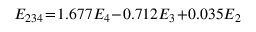<formula> <loc_0><loc_0><loc_500><loc_500>\begin{array} { r } { E _ { 2 3 4 } \, = \, 1 . 6 7 7 E _ { 4 } \, - \, 0 . 7 1 2 E _ { 3 } \, + \, 0 . 0 3 5 E _ { 2 } } \end{array}</formula> 